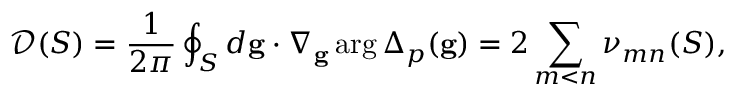<formula> <loc_0><loc_0><loc_500><loc_500>\mathcal { D } ( S ) = \frac { 1 } { 2 \pi } \oint _ { S } d g \cdot \nabla _ { g } \arg \Delta _ { p } ( g ) = 2 \sum _ { m < n } \nu _ { m n } ( S ) ,</formula> 